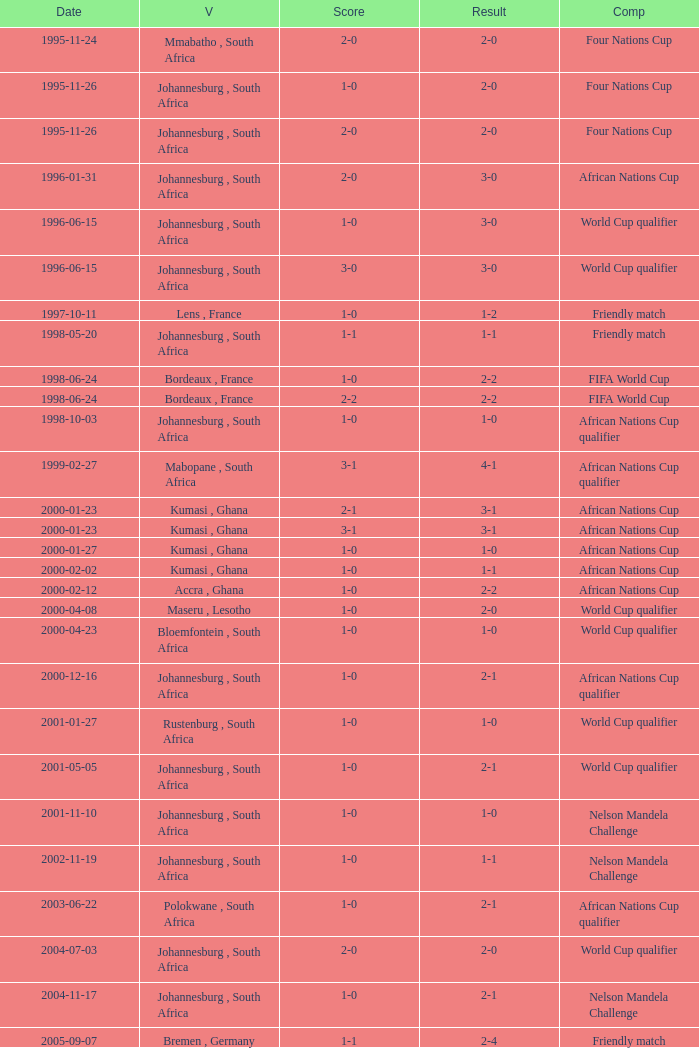What is the Venue of the Competition on 2001-05-05? Johannesburg , South Africa. 